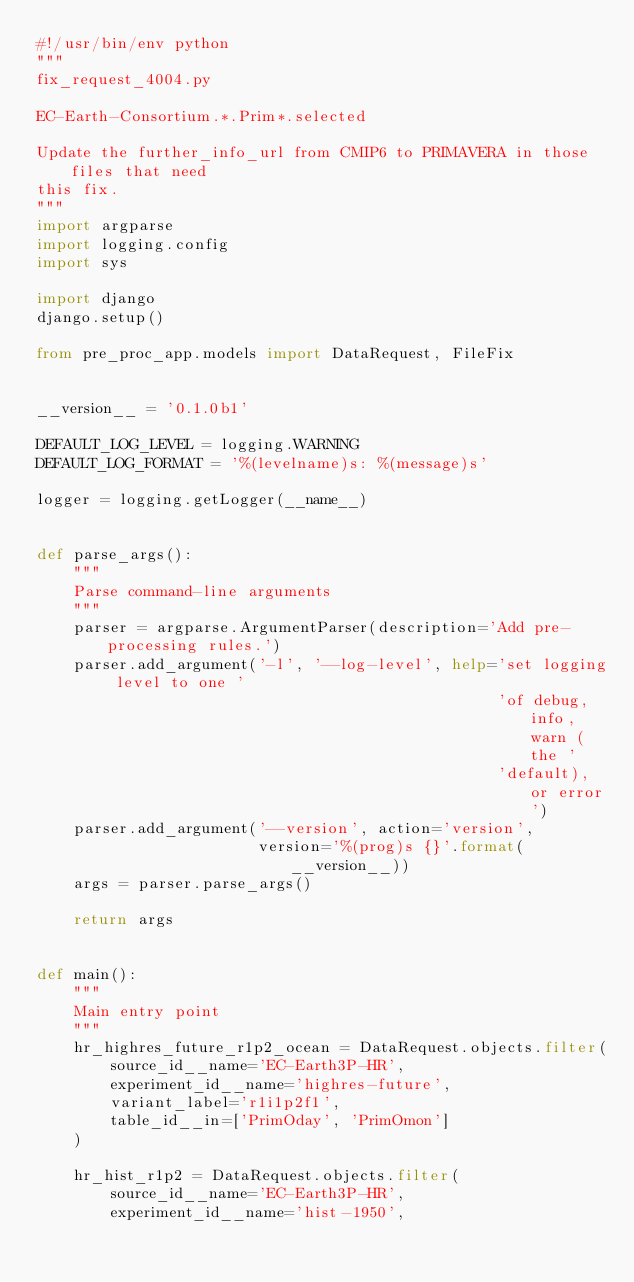<code> <loc_0><loc_0><loc_500><loc_500><_Python_>#!/usr/bin/env python
"""
fix_request_4004.py

EC-Earth-Consortium.*.Prim*.selected

Update the further_info_url from CMIP6 to PRIMAVERA in those files that need
this fix.
"""
import argparse
import logging.config
import sys

import django
django.setup()

from pre_proc_app.models import DataRequest, FileFix


__version__ = '0.1.0b1'

DEFAULT_LOG_LEVEL = logging.WARNING
DEFAULT_LOG_FORMAT = '%(levelname)s: %(message)s'

logger = logging.getLogger(__name__)


def parse_args():
    """
    Parse command-line arguments
    """
    parser = argparse.ArgumentParser(description='Add pre-processing rules.')
    parser.add_argument('-l', '--log-level', help='set logging level to one '
                                                  'of debug, info, warn (the '
                                                  'default), or error')
    parser.add_argument('--version', action='version',
                        version='%(prog)s {}'.format(__version__))
    args = parser.parse_args()

    return args


def main():
    """
    Main entry point
    """
    hr_highres_future_r1p2_ocean = DataRequest.objects.filter(
        source_id__name='EC-Earth3P-HR',
        experiment_id__name='highres-future',
        variant_label='r1i1p2f1',
        table_id__in=['PrimOday', 'PrimOmon']
    )

    hr_hist_r1p2 = DataRequest.objects.filter(
        source_id__name='EC-Earth3P-HR',
        experiment_id__name='hist-1950',</code> 